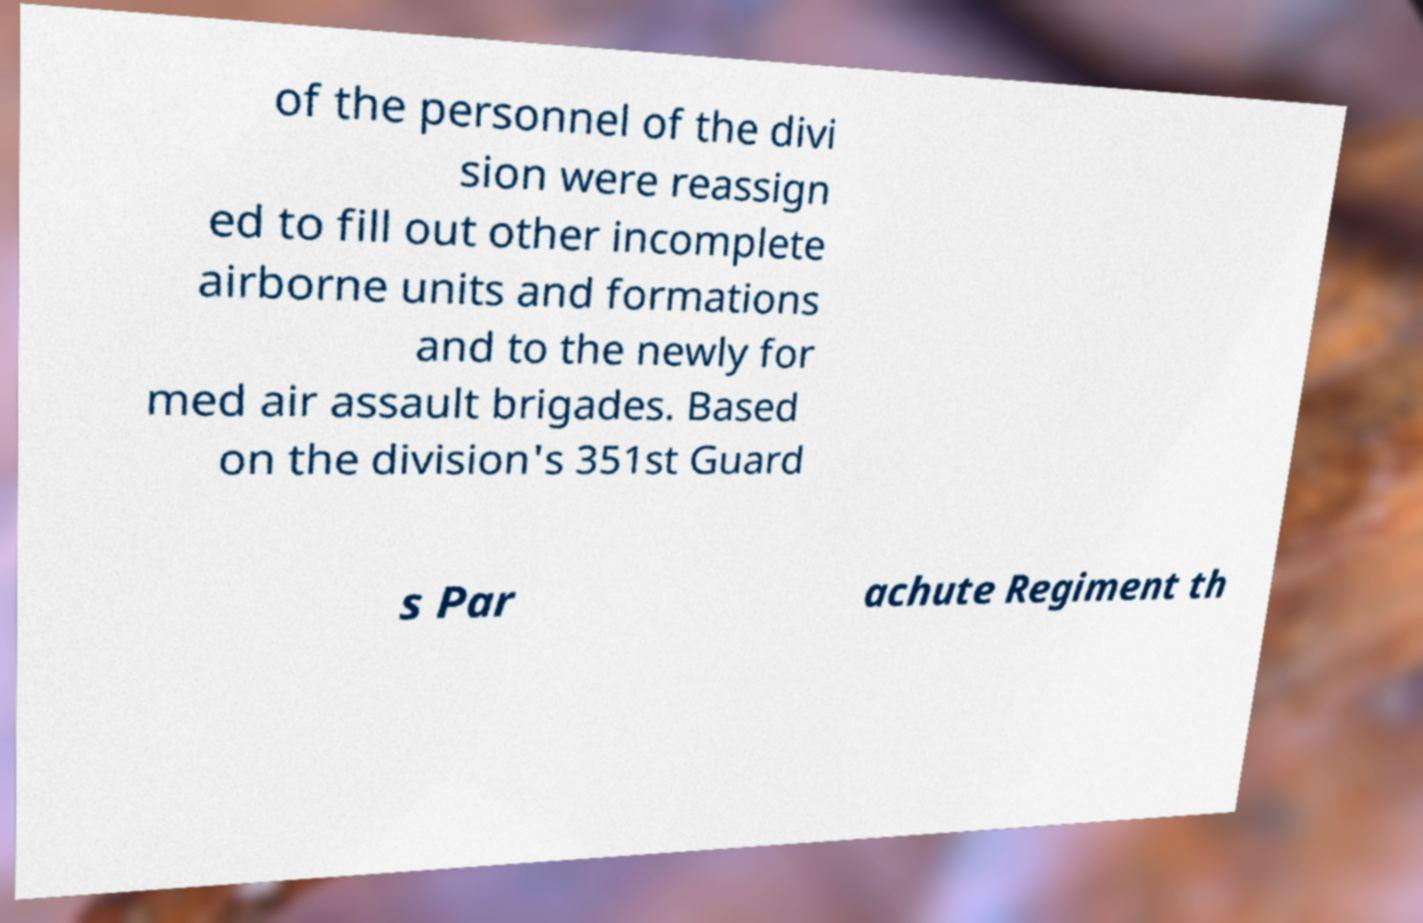Could you assist in decoding the text presented in this image and type it out clearly? of the personnel of the divi sion were reassign ed to fill out other incomplete airborne units and formations and to the newly for med air assault brigades. Based on the division's 351st Guard s Par achute Regiment th 